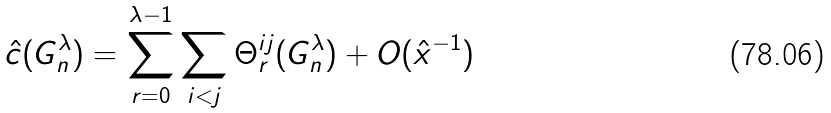<formula> <loc_0><loc_0><loc_500><loc_500>\hat { c } ( G _ { n } ^ { \lambda } ) = \sum _ { r = 0 } ^ { \lambda - 1 } \sum _ { i < j } \Theta _ { r } ^ { i j } ( G _ { n } ^ { \lambda } ) + O ( \hat { x } ^ { - 1 } )</formula> 